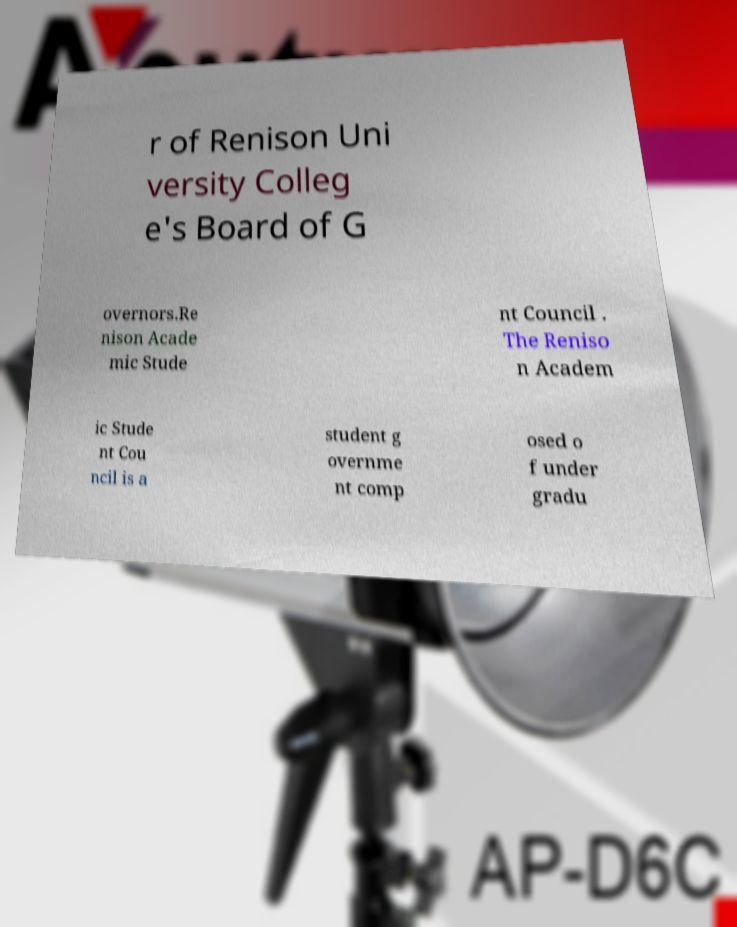For documentation purposes, I need the text within this image transcribed. Could you provide that? r of Renison Uni versity Colleg e's Board of G overnors.Re nison Acade mic Stude nt Council . The Reniso n Academ ic Stude nt Cou ncil is a student g overnme nt comp osed o f under gradu 